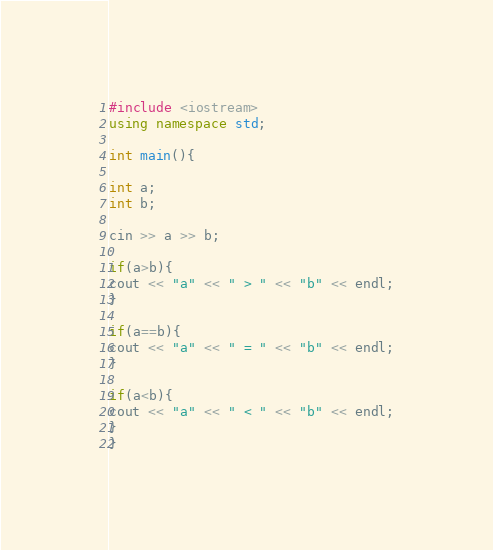<code> <loc_0><loc_0><loc_500><loc_500><_C++_>#include <iostream>
using namespace std;

int main(){

int a;
int b;

cin >> a >> b; 

if(a>b){
cout << "a" << " > " << "b" << endl;
}

if(a==b){
cout << "a" << " = " << "b" << endl;
}

if(a<b){
cout << "a" << " < " << "b" << endl;
}
}</code> 